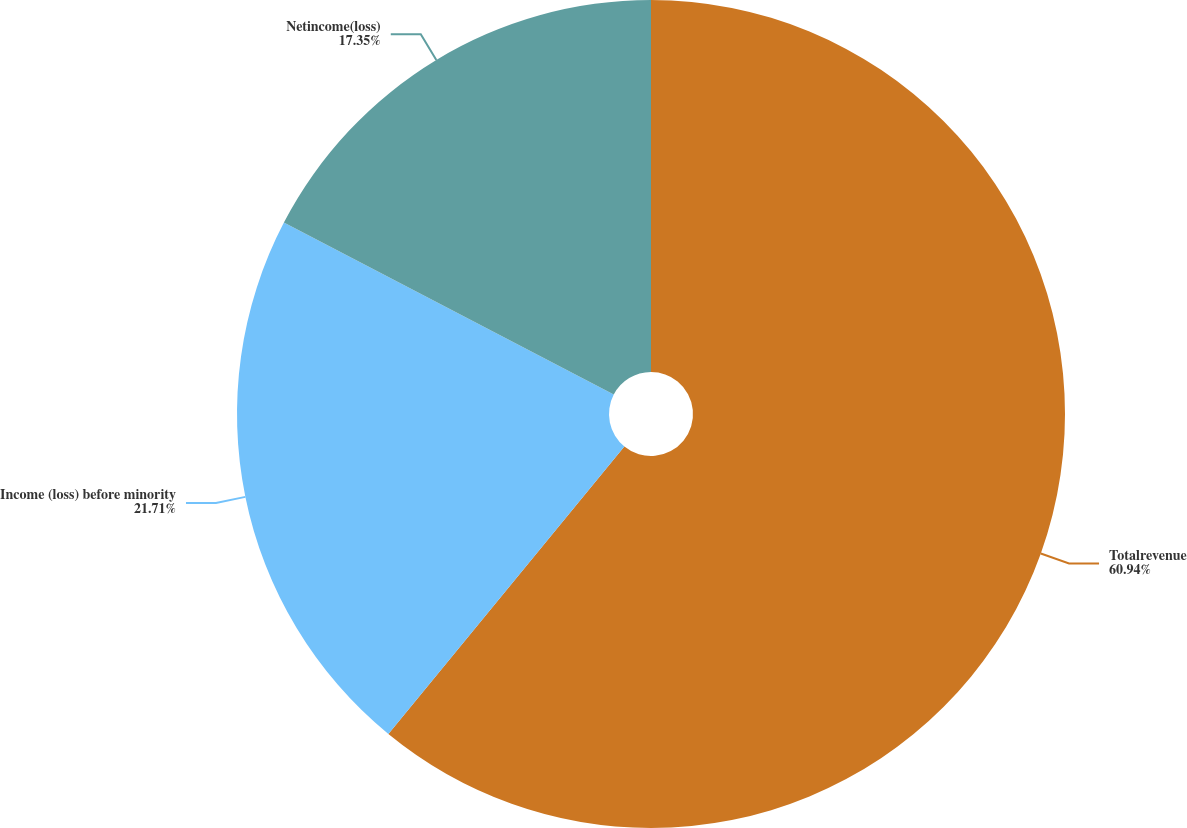Convert chart. <chart><loc_0><loc_0><loc_500><loc_500><pie_chart><fcel>Totalrevenue<fcel>Income (loss) before minority<fcel>Netincome(loss)<nl><fcel>60.93%<fcel>21.71%<fcel>17.35%<nl></chart> 